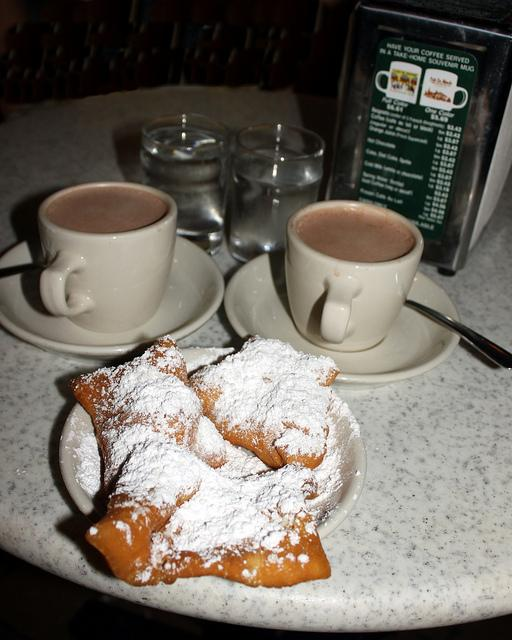What is in the tin box? Please explain your reasoning. napkins. Its a place to store napkins 